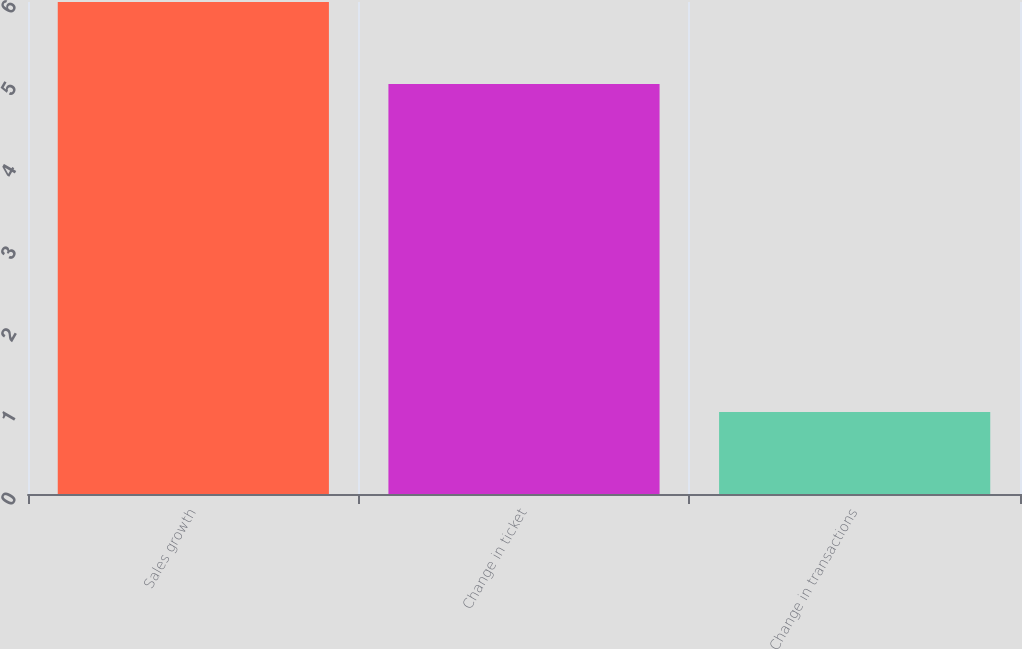Convert chart. <chart><loc_0><loc_0><loc_500><loc_500><bar_chart><fcel>Sales growth<fcel>Change in ticket<fcel>Change in transactions<nl><fcel>6<fcel>5<fcel>1<nl></chart> 